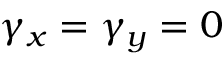<formula> <loc_0><loc_0><loc_500><loc_500>\gamma _ { x } = \gamma _ { y } = 0</formula> 